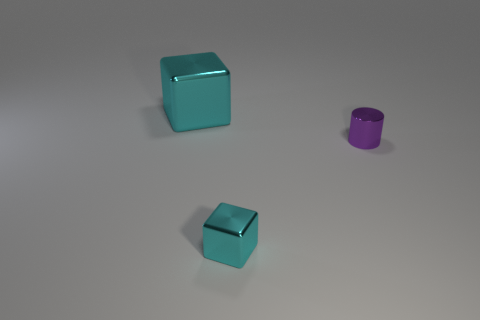How many other things are there of the same material as the large cyan object?
Ensure brevity in your answer.  2. How many other objects are the same shape as the big cyan object?
Ensure brevity in your answer.  1. What number of cubes are big cyan metal things or cyan shiny objects?
Ensure brevity in your answer.  2. There is a cube to the right of the cyan thing that is on the left side of the small cyan block; is there a big cyan thing that is on the left side of it?
Provide a short and direct response. Yes. There is another shiny thing that is the same shape as the big cyan thing; what color is it?
Keep it short and to the point. Cyan. What number of purple things are small metallic cylinders or big cylinders?
Your response must be concise. 1. There is a cyan object right of the cyan object that is behind the small cube; what is it made of?
Provide a short and direct response. Metal. Is the purple object the same shape as the big cyan object?
Provide a short and direct response. No. There is a metallic block that is the same size as the purple cylinder; what color is it?
Your response must be concise. Cyan. Are there any cubes that have the same color as the metal cylinder?
Provide a short and direct response. No. 